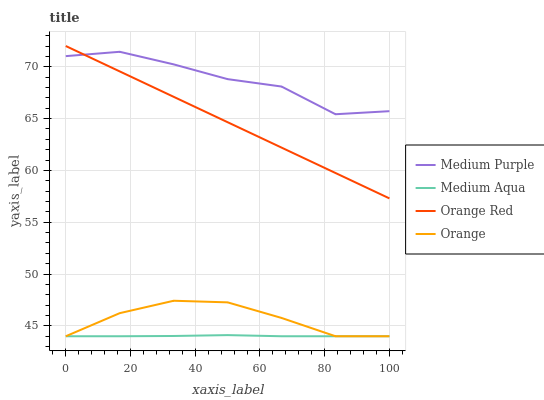Does Medium Aqua have the minimum area under the curve?
Answer yes or no. Yes. Does Medium Purple have the maximum area under the curve?
Answer yes or no. Yes. Does Orange have the minimum area under the curve?
Answer yes or no. No. Does Orange have the maximum area under the curve?
Answer yes or no. No. Is Orange Red the smoothest?
Answer yes or no. Yes. Is Medium Purple the roughest?
Answer yes or no. Yes. Is Orange the smoothest?
Answer yes or no. No. Is Orange the roughest?
Answer yes or no. No. Does Orange have the lowest value?
Answer yes or no. Yes. Does Orange Red have the lowest value?
Answer yes or no. No. Does Orange Red have the highest value?
Answer yes or no. Yes. Does Orange have the highest value?
Answer yes or no. No. Is Orange less than Medium Purple?
Answer yes or no. Yes. Is Orange Red greater than Medium Aqua?
Answer yes or no. Yes. Does Medium Purple intersect Orange Red?
Answer yes or no. Yes. Is Medium Purple less than Orange Red?
Answer yes or no. No. Is Medium Purple greater than Orange Red?
Answer yes or no. No. Does Orange intersect Medium Purple?
Answer yes or no. No. 